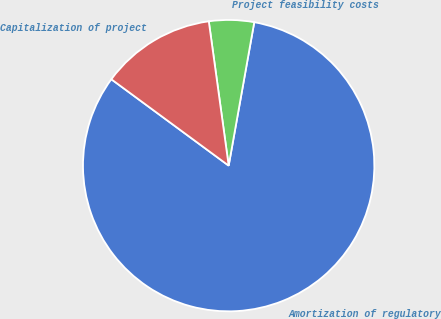Convert chart to OTSL. <chart><loc_0><loc_0><loc_500><loc_500><pie_chart><fcel>Amortization of regulatory<fcel>Project feasibility costs<fcel>Capitalization of project<nl><fcel>82.29%<fcel>4.99%<fcel>12.72%<nl></chart> 